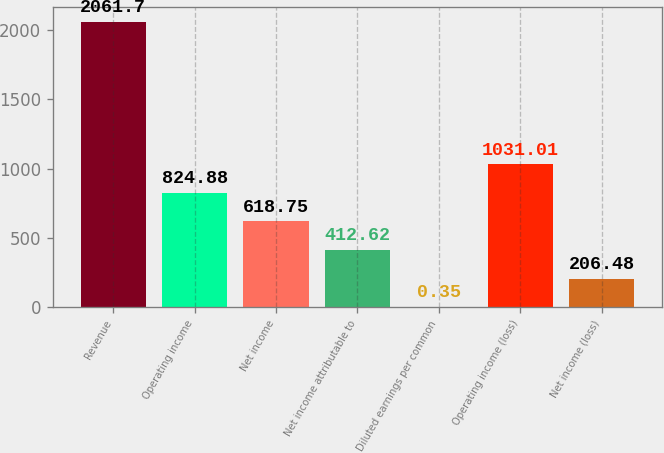<chart> <loc_0><loc_0><loc_500><loc_500><bar_chart><fcel>Revenue<fcel>Operating income<fcel>Net income<fcel>Net income attributable to<fcel>Diluted earnings per common<fcel>Operating income (loss)<fcel>Net income (loss)<nl><fcel>2061.7<fcel>824.88<fcel>618.75<fcel>412.62<fcel>0.35<fcel>1031.01<fcel>206.48<nl></chart> 